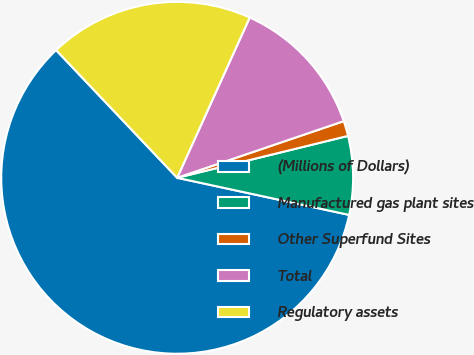Convert chart to OTSL. <chart><loc_0><loc_0><loc_500><loc_500><pie_chart><fcel>(Millions of Dollars)<fcel>Manufactured gas plant sites<fcel>Other Superfund Sites<fcel>Total<fcel>Regulatory assets<nl><fcel>59.54%<fcel>7.21%<fcel>1.39%<fcel>13.02%<fcel>18.84%<nl></chart> 